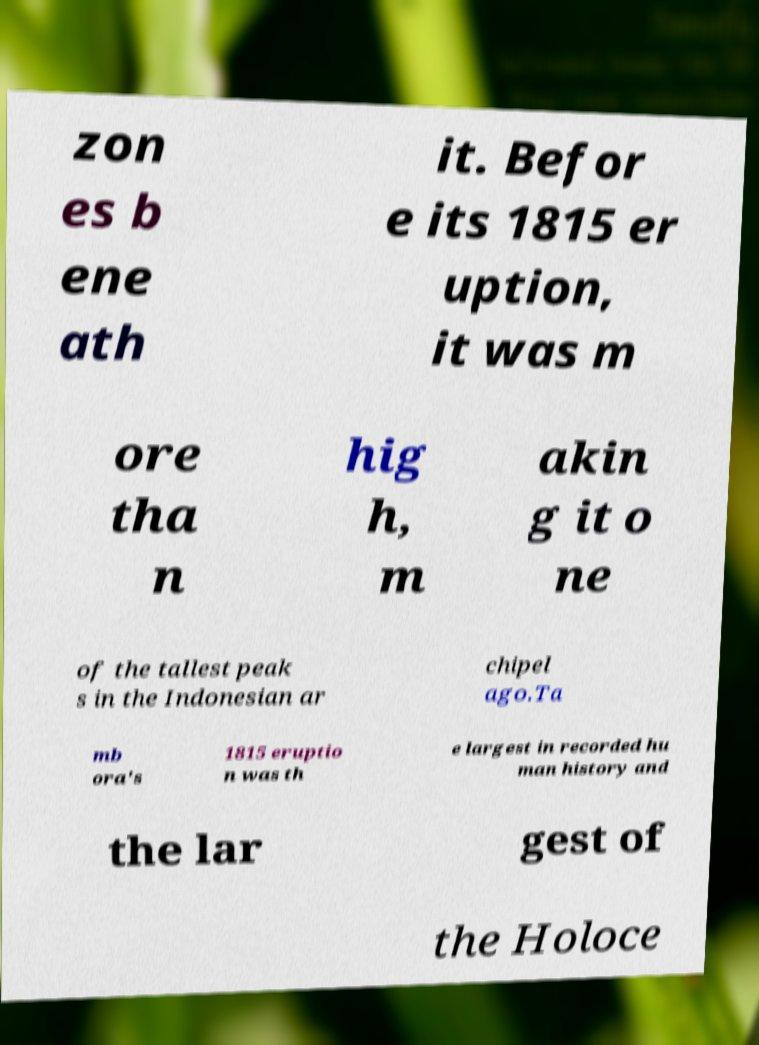For documentation purposes, I need the text within this image transcribed. Could you provide that? zon es b ene ath it. Befor e its 1815 er uption, it was m ore tha n hig h, m akin g it o ne of the tallest peak s in the Indonesian ar chipel ago.Ta mb ora's 1815 eruptio n was th e largest in recorded hu man history and the lar gest of the Holoce 